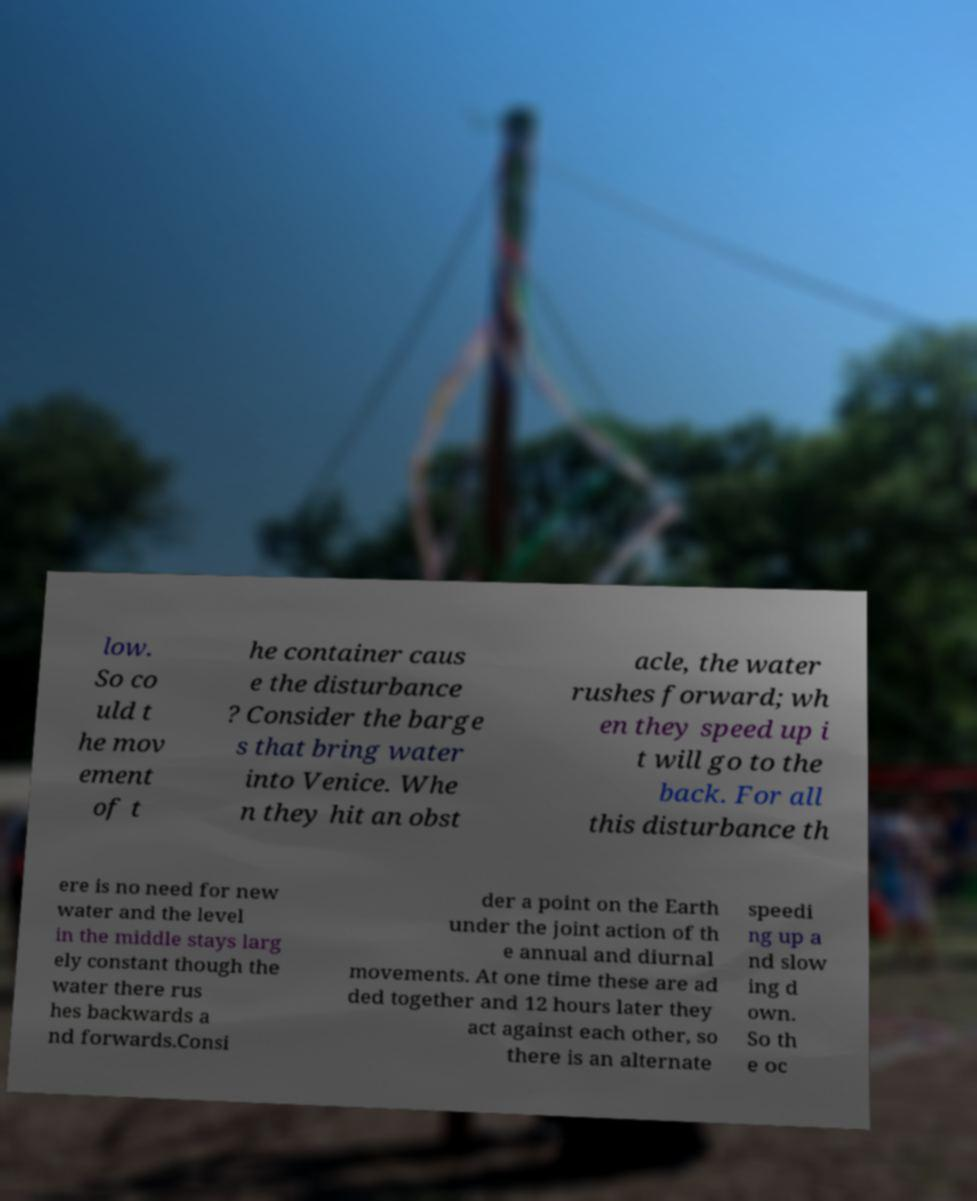Could you extract and type out the text from this image? low. So co uld t he mov ement of t he container caus e the disturbance ? Consider the barge s that bring water into Venice. Whe n they hit an obst acle, the water rushes forward; wh en they speed up i t will go to the back. For all this disturbance th ere is no need for new water and the level in the middle stays larg ely constant though the water there rus hes backwards a nd forwards.Consi der a point on the Earth under the joint action of th e annual and diurnal movements. At one time these are ad ded together and 12 hours later they act against each other, so there is an alternate speedi ng up a nd slow ing d own. So th e oc 